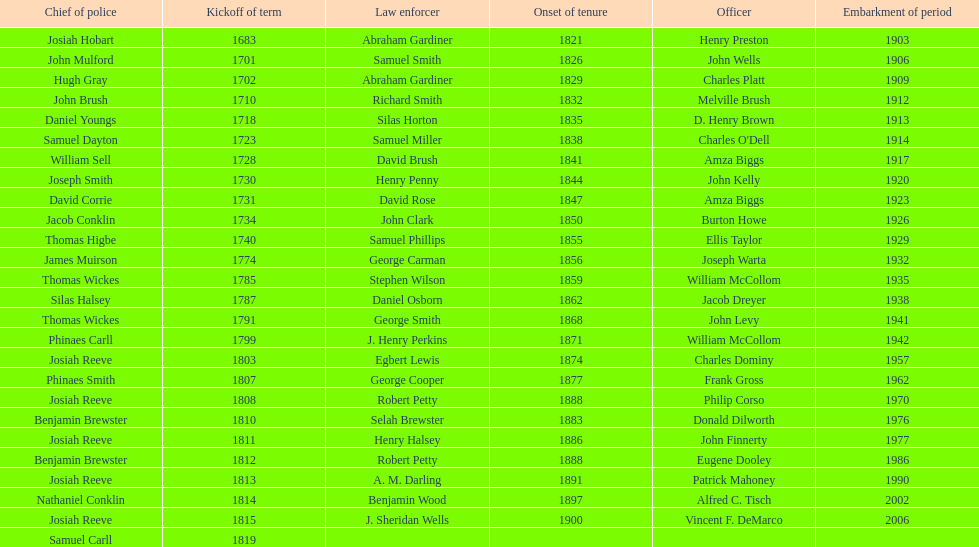What is the number of sheriff's with the last name smith? 5. 